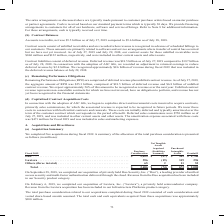According to Cisco Systems's financial document, What did the total purchase consideration related to our acquisitions completed during fiscal 2019 consist of? cash consideration and vested share-based awards assumed. The document states: "sitions completed during fiscal 2019 consisted of cash consideration and vested share-based awards assumed. The total cash and cash equivalents acquir..." Also, What company did the company acquire in fiscal 2019? Luxtera, Inc. (“Luxtera”), a privately held semiconductor company. The document states: "February 6, 2019, we completed our acquisition of Luxtera, Inc. (“Luxtera”), a privately held semiconductor company. Revenue from the Luxtera acquisit..." Also, What the purchase consideration from Luxtera? According to the financial document, 596 (in millions). The relevant text states: "will Duo . $ 2,025 $ (57) $ 342 $ 1,740 Luxtera . 596 (19) 319 296 Others (three in total) . 65 2 11 52 Total . $ 2,686 $ (74) $ 672 $ 2,088..." Also, can you calculate: What was the difference in Goodwill between Duo and Luxtera? Based on the calculation: 1,740-296, the result is 1444 (in millions). This is based on the information: "2,025 $ (57) $ 342 $ 1,740 Luxtera . 596 (19) 319 296 Others (three in total) . 65 2 11 52 Total . $ 2,686 $ (74) $ 672 $ 2,088 ible Assets Goodwill Duo . $ 2,025 $ (57) $ 342 $ 1,740 Luxtera . 596 (1..." The key data points involved are: 1,740, 296. Also, can you calculate: What was the difference in Purchased intangible assets between Luxtera and Others? Based on the calculation: 319-11, the result is 308 (in millions). This is based on the information: ". 596 (19) 319 296 Others (three in total) . 65 2 11 52 Total . $ 2,686 $ (74) $ 672 $ 2,088 . $ 2,025 $ (57) $ 342 $ 1,740 Luxtera . 596 (19) 319 296 Others (three in total) . 65 2 11 52 Total . $ 2,..." The key data points involved are: 11, 319. Additionally, What is the acquisition with the highest Purchase Consideration? According to the financial document, Duo. The relevant text states: "Purchased Intangible Assets Goodwill Duo . $ 2,025 $ (57) $ 342 $ 1,740 Luxtera . 596 (19) 319 296 Others (three in total) . 65 2 11 52 Tota..." 